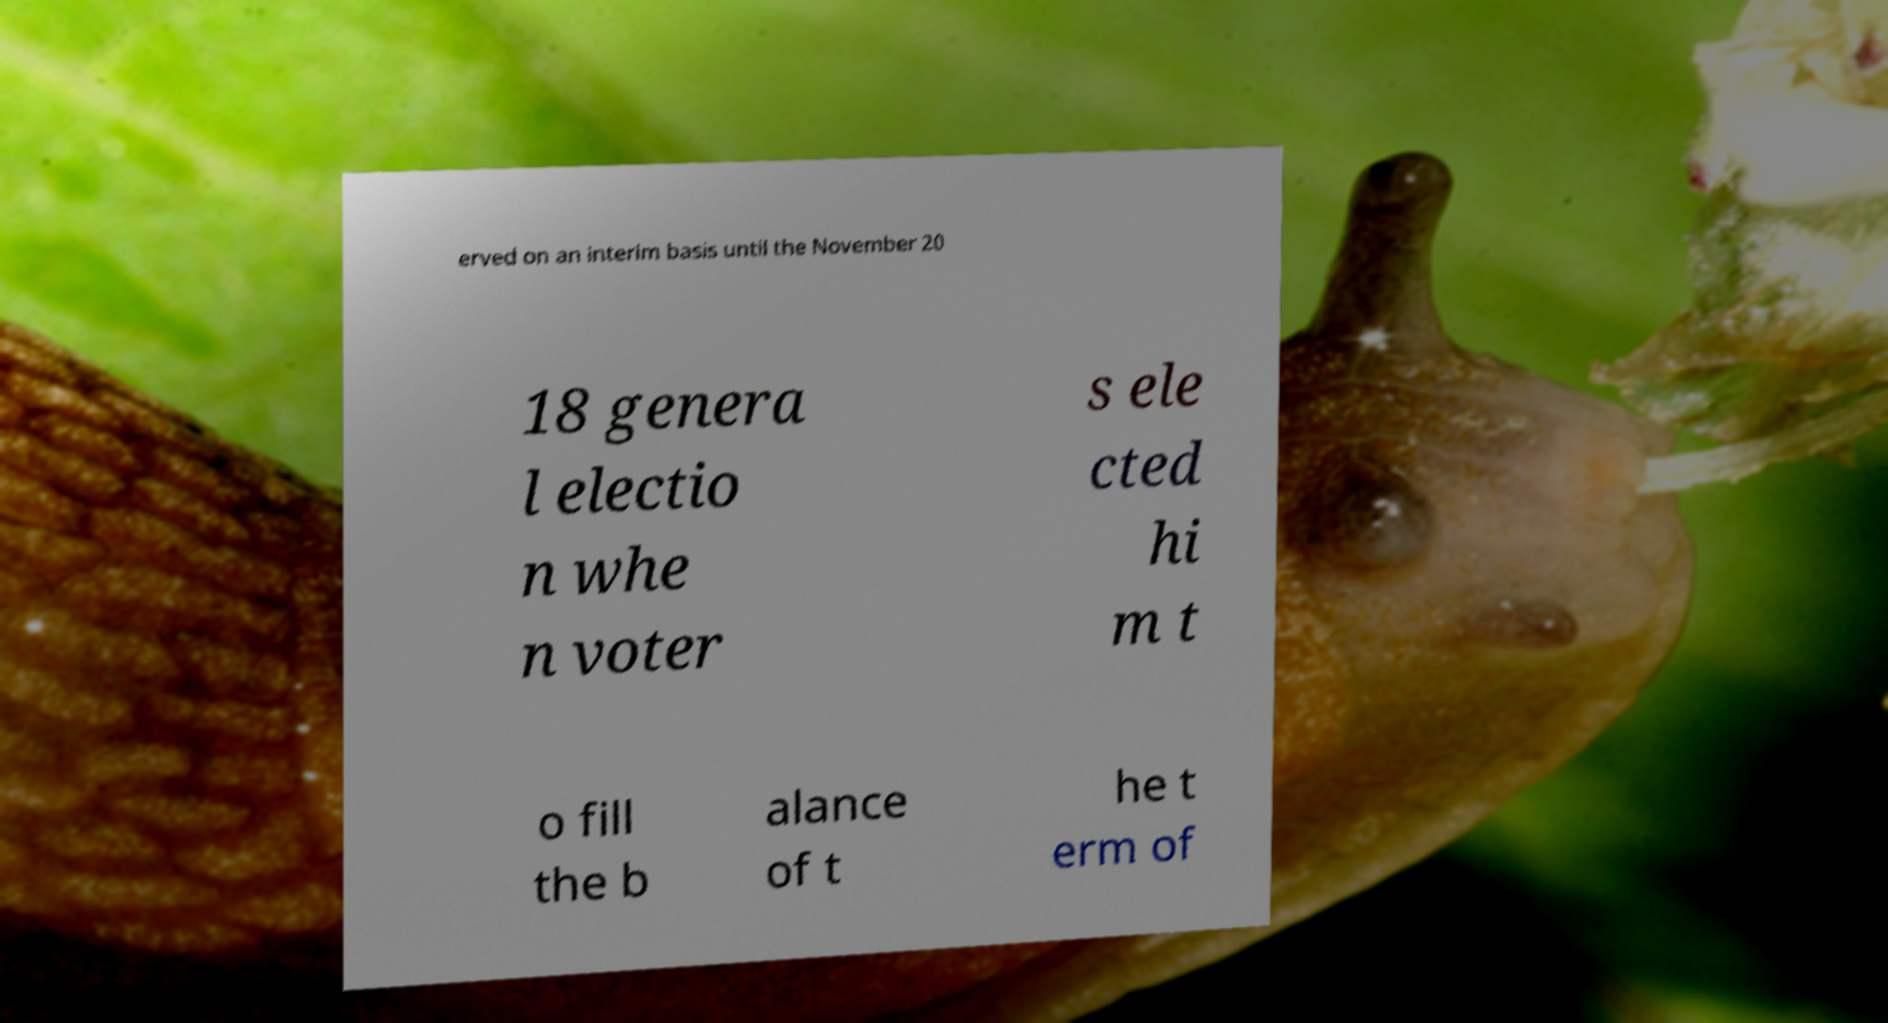Can you accurately transcribe the text from the provided image for me? erved on an interim basis until the November 20 18 genera l electio n whe n voter s ele cted hi m t o fill the b alance of t he t erm of 